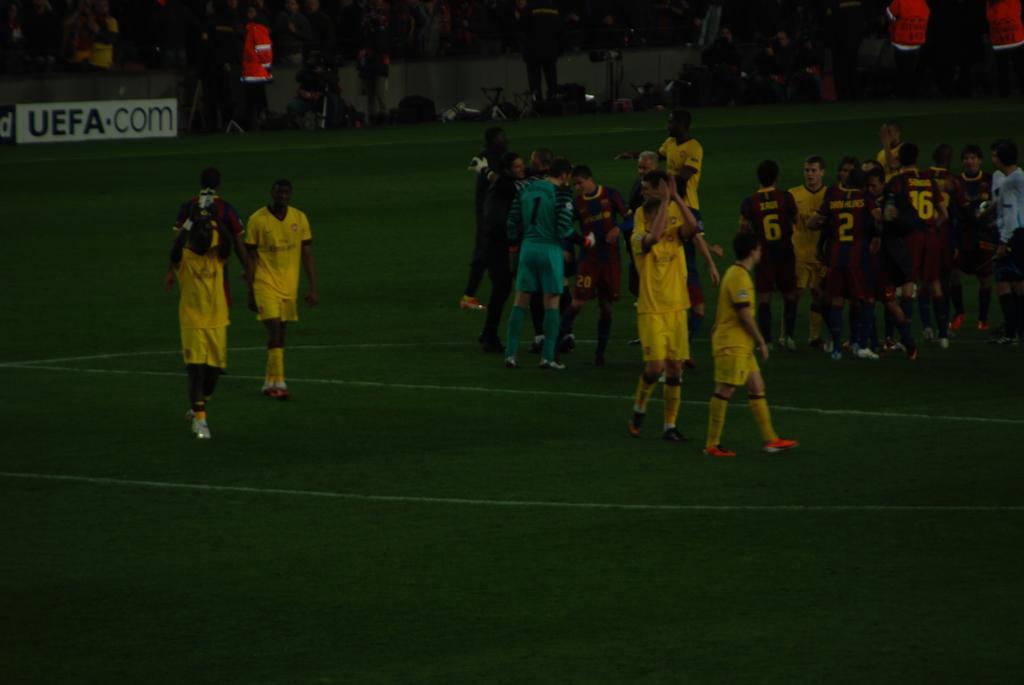How would you summarize this image in a sentence or two? In this image in the center there are some people who are wearing jersey, and at the bottom there is ground. And in the background there are group of people and some boards and some other objects, and their might be a wall. 